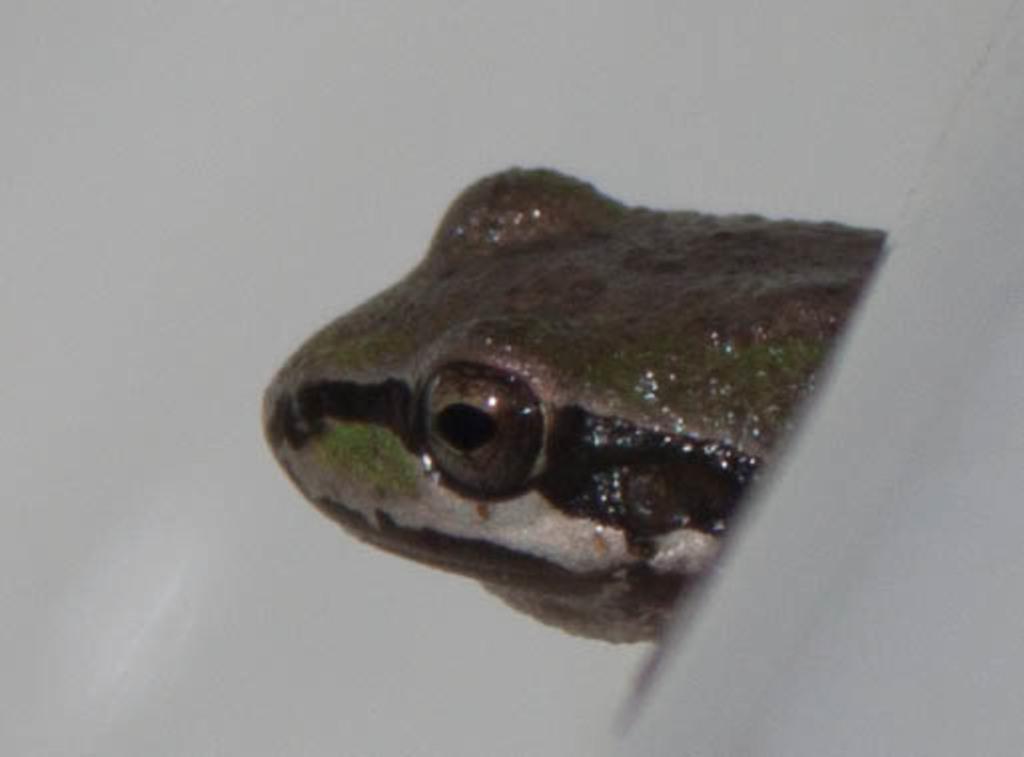Describe this image in one or two sentences. In this image, I can see the face of a reptile. The background looks white in color. 